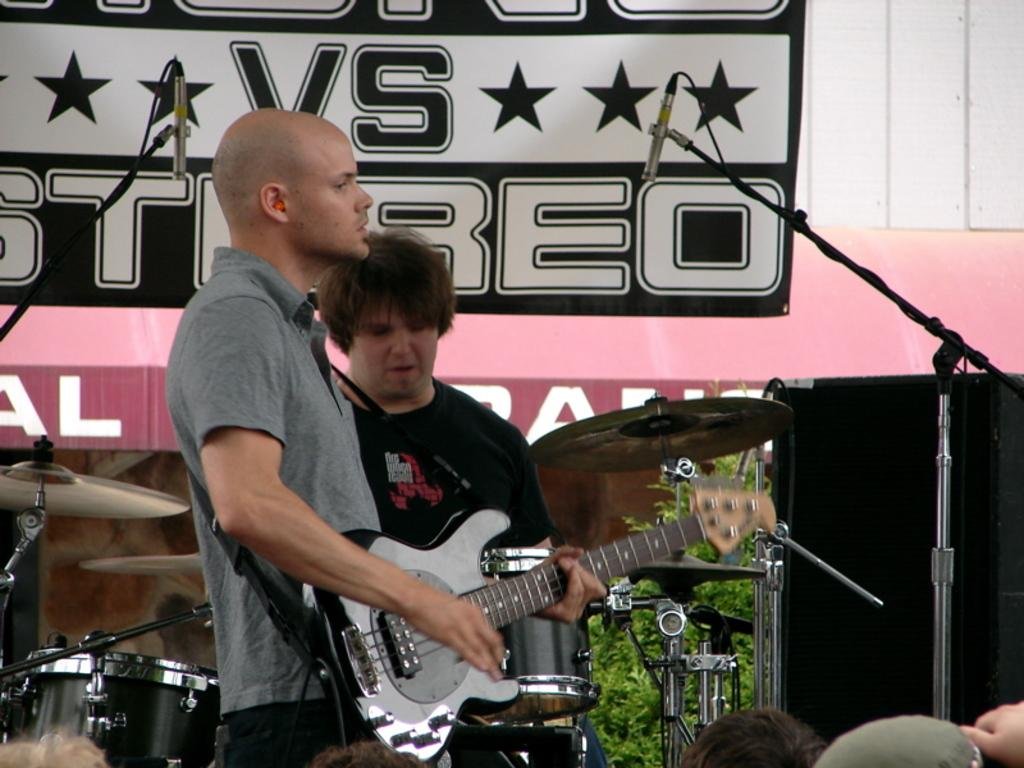What are the people in the image doing? The people in the image are standing and holding guitars. Is there any musical activity happening in the image? Yes, there is a person playing drums in the image. What type of sand can be seen in the image? There is no sand present in the image. Can you tell me how many wrens are visible in the image? There are no wrens present in the image. 